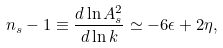Convert formula to latex. <formula><loc_0><loc_0><loc_500><loc_500>n _ { s } - 1 \equiv \frac { d \ln A _ { s } ^ { 2 } } { d \ln k } \simeq - 6 \epsilon + 2 \eta ,</formula> 